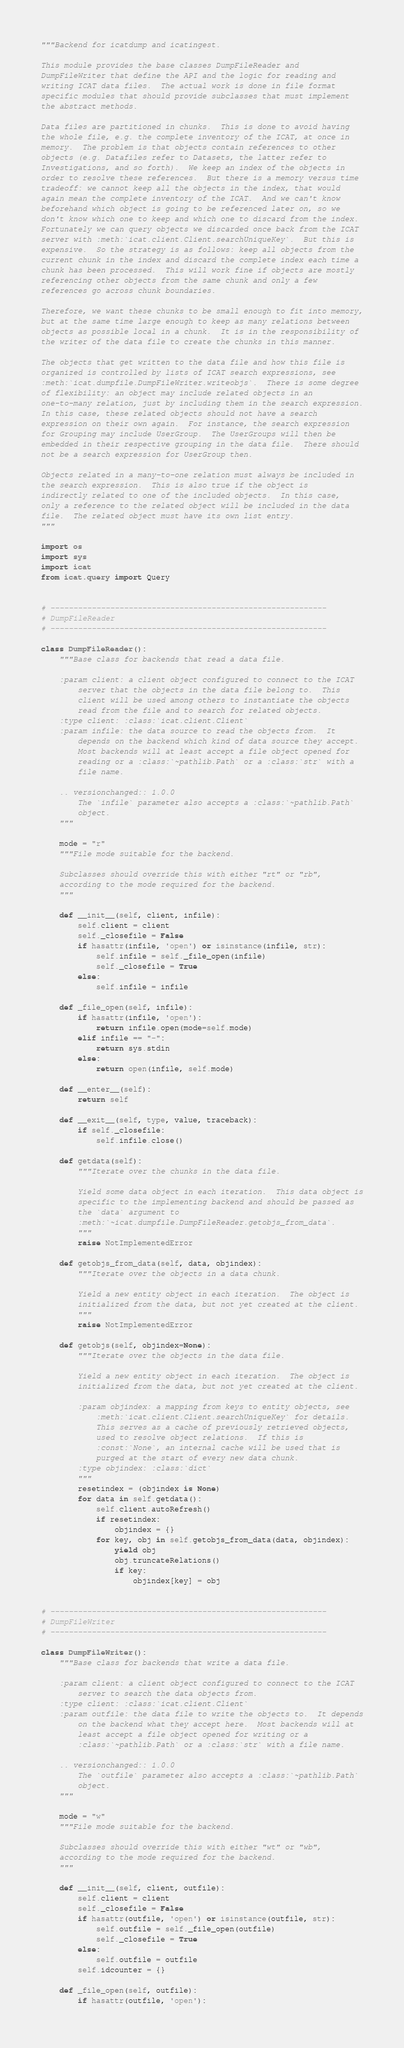<code> <loc_0><loc_0><loc_500><loc_500><_Python_>"""Backend for icatdump and icatingest.

This module provides the base classes DumpFileReader and
DumpFileWriter that define the API and the logic for reading and
writing ICAT data files.  The actual work is done in file format
specific modules that should provide subclasses that must implement
the abstract methods.

Data files are partitioned in chunks.  This is done to avoid having
the whole file, e.g. the complete inventory of the ICAT, at once in
memory.  The problem is that objects contain references to other
objects (e.g. Datafiles refer to Datasets, the latter refer to
Investigations, and so forth).  We keep an index of the objects in
order to resolve these references.  But there is a memory versus time
tradeoff: we cannot keep all the objects in the index, that would
again mean the complete inventory of the ICAT.  And we can't know
beforehand which object is going to be referenced later on, so we
don't know which one to keep and which one to discard from the index.
Fortunately we can query objects we discarded once back from the ICAT
server with :meth:`icat.client.Client.searchUniqueKey`.  But this is
expensive.  So the strategy is as follows: keep all objects from the
current chunk in the index and discard the complete index each time a
chunk has been processed.  This will work fine if objects are mostly
referencing other objects from the same chunk and only a few
references go across chunk boundaries.

Therefore, we want these chunks to be small enough to fit into memory,
but at the same time large enough to keep as many relations between
objects as possible local in a chunk.  It is in the responsibility of
the writer of the data file to create the chunks in this manner.

The objects that get written to the data file and how this file is
organized is controlled by lists of ICAT search expressions, see
:meth:`icat.dumpfile.DumpFileWriter.writeobjs`.  There is some degree
of flexibility: an object may include related objects in an
one-to-many relation, just by including them in the search expression.
In this case, these related objects should not have a search
expression on their own again.  For instance, the search expression
for Grouping may include UserGroup.  The UserGroups will then be
embedded in their respective grouping in the data file.  There should
not be a search expression for UserGroup then.

Objects related in a many-to-one relation must always be included in
the search expression.  This is also true if the object is
indirectly related to one of the included objects.  In this case,
only a reference to the related object will be included in the data
file.  The related object must have its own list entry.
"""

import os
import sys
import icat
from icat.query import Query


# ------------------------------------------------------------
# DumpFileReader
# ------------------------------------------------------------

class DumpFileReader():
    """Base class for backends that read a data file.

    :param client: a client object configured to connect to the ICAT
        server that the objects in the data file belong to.  This
        client will be used among others to instantiate the objects
        read from the file and to search for related objects.
    :type client: :class:`icat.client.Client`
    :param infile: the data source to read the objects from.  It
        depends on the backend which kind of data source they accept.
        Most backends will at least accept a file object opened for
        reading or a :class:`~pathlib.Path` or a :class:`str` with a
        file name.

    .. versionchanged:: 1.0.0
        The `infile` parameter also accepts a :class:`~pathlib.Path`
        object.
    """

    mode = "r"
    """File mode suitable for the backend.

    Subclasses should override this with either "rt" or "rb",
    according to the mode required for the backend.
    """

    def __init__(self, client, infile):
        self.client = client
        self._closefile = False
        if hasattr(infile, 'open') or isinstance(infile, str):
            self.infile = self._file_open(infile)
            self._closefile = True
        else:
            self.infile = infile

    def _file_open(self, infile):
        if hasattr(infile, 'open'):
            return infile.open(mode=self.mode)
        elif infile == "-":
            return sys.stdin
        else:
            return open(infile, self.mode)

    def __enter__(self):
        return self

    def __exit__(self, type, value, traceback):
        if self._closefile:
            self.infile.close()

    def getdata(self):
        """Iterate over the chunks in the data file.

        Yield some data object in each iteration.  This data object is
        specific to the implementing backend and should be passed as
        the `data` argument to
        :meth:`~icat.dumpfile.DumpFileReader.getobjs_from_data`.
        """
        raise NotImplementedError

    def getobjs_from_data(self, data, objindex):
        """Iterate over the objects in a data chunk.

        Yield a new entity object in each iteration.  The object is
        initialized from the data, but not yet created at the client.
        """
        raise NotImplementedError

    def getobjs(self, objindex=None):
        """Iterate over the objects in the data file.

        Yield a new entity object in each iteration.  The object is
        initialized from the data, but not yet created at the client.

        :param objindex: a mapping from keys to entity objects, see
            :meth:`icat.client.Client.searchUniqueKey` for details.
            This serves as a cache of previously retrieved objects,
            used to resolve object relations.  If this is
            :const:`None`, an internal cache will be used that is
            purged at the start of every new data chunk.
        :type objindex: :class:`dict`
        """
        resetindex = (objindex is None)
        for data in self.getdata():
            self.client.autoRefresh()
            if resetindex:
                objindex = {}
            for key, obj in self.getobjs_from_data(data, objindex):
                yield obj
                obj.truncateRelations()
                if key:
                    objindex[key] = obj


# ------------------------------------------------------------
# DumpFileWriter
# ------------------------------------------------------------

class DumpFileWriter():
    """Base class for backends that write a data file.

    :param client: a client object configured to connect to the ICAT
        server to search the data objects from.
    :type client: :class:`icat.client.Client`
    :param outfile: the data file to write the objects to.  It depends
        on the backend what they accept here.  Most backends will at
        least accept a file object opened for writing or a
        :class:`~pathlib.Path` or a :class:`str` with a file name.

    .. versionchanged:: 1.0.0
        The `outfile` parameter also accepts a :class:`~pathlib.Path`
        object.
    """

    mode = "w"
    """File mode suitable for the backend.

    Subclasses should override this with either "wt" or "wb",
    according to the mode required for the backend.
    """

    def __init__(self, client, outfile):
        self.client = client
        self._closefile = False
        if hasattr(outfile, 'open') or isinstance(outfile, str):
            self.outfile = self._file_open(outfile)
            self._closefile = True
        else:
            self.outfile = outfile
        self.idcounter = {}

    def _file_open(self, outfile):
        if hasattr(outfile, 'open'):</code> 